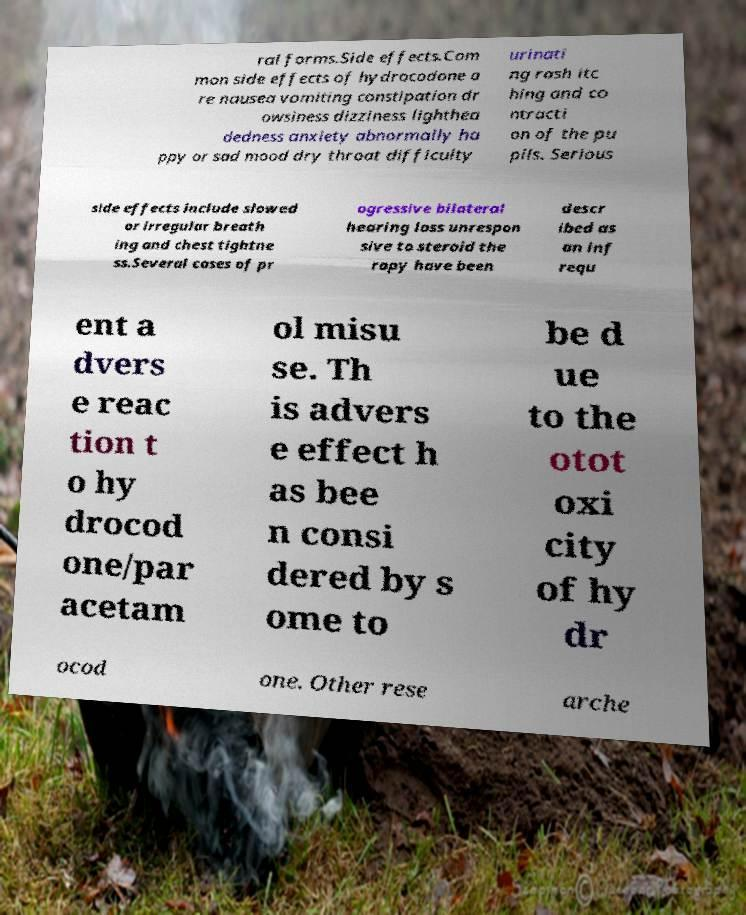Could you extract and type out the text from this image? ral forms.Side effects.Com mon side effects of hydrocodone a re nausea vomiting constipation dr owsiness dizziness lighthea dedness anxiety abnormally ha ppy or sad mood dry throat difficulty urinati ng rash itc hing and co ntracti on of the pu pils. Serious side effects include slowed or irregular breath ing and chest tightne ss.Several cases of pr ogressive bilateral hearing loss unrespon sive to steroid the rapy have been descr ibed as an inf requ ent a dvers e reac tion t o hy drocod one/par acetam ol misu se. Th is advers e effect h as bee n consi dered by s ome to be d ue to the otot oxi city of hy dr ocod one. Other rese arche 